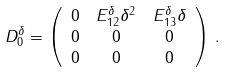Convert formula to latex. <formula><loc_0><loc_0><loc_500><loc_500>D _ { 0 } ^ { \delta } & = \left ( \begin{array} { c c c } 0 & E _ { 1 2 } ^ { \delta } \delta ^ { 2 } & E _ { 1 3 } ^ { \delta } \delta \\ 0 & 0 & 0 \\ 0 & 0 & 0 \end{array} \right ) \, .</formula> 